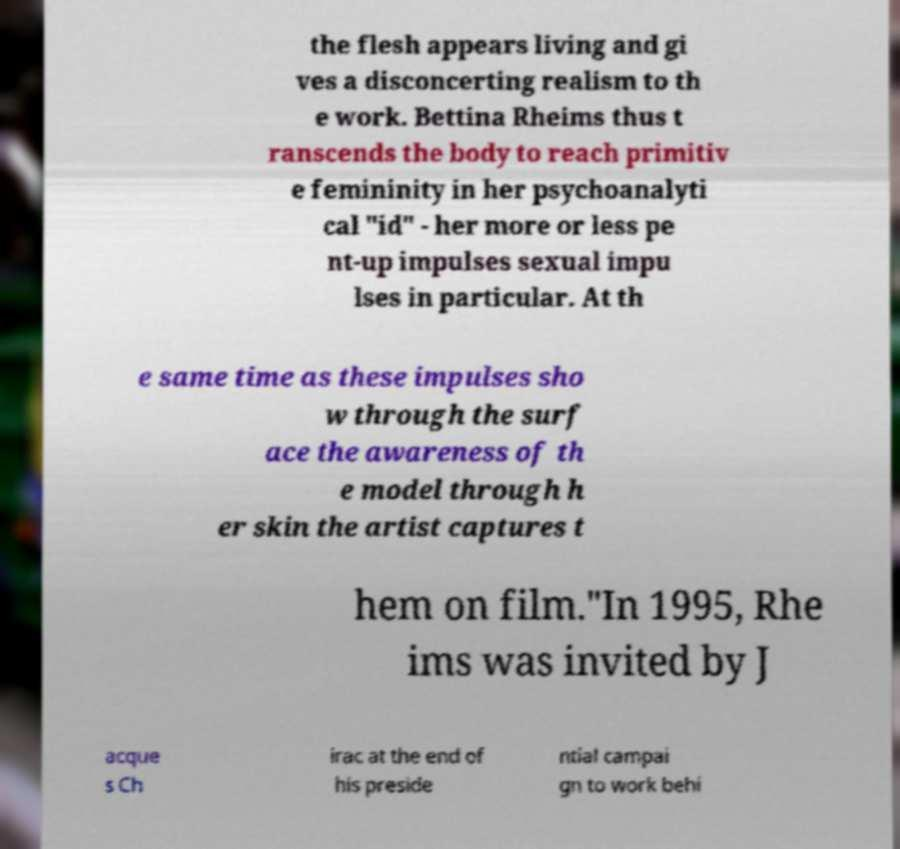For documentation purposes, I need the text within this image transcribed. Could you provide that? the flesh appears living and gi ves a disconcerting realism to th e work. Bettina Rheims thus t ranscends the body to reach primitiv e femininity in her psychoanalyti cal "id" - her more or less pe nt-up impulses sexual impu lses in particular. At th e same time as these impulses sho w through the surf ace the awareness of th e model through h er skin the artist captures t hem on film."In 1995, Rhe ims was invited by J acque s Ch irac at the end of his preside ntial campai gn to work behi 